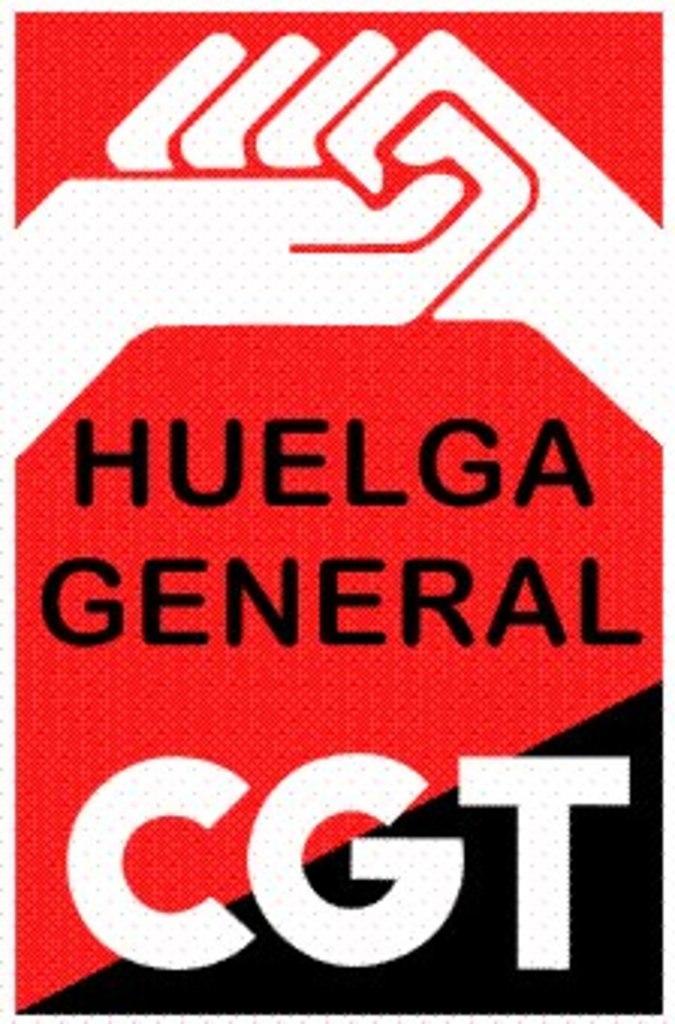What 3 letters are in white?
Your answer should be very brief. Cgt. What kind of general?
Provide a short and direct response. Huelga. 